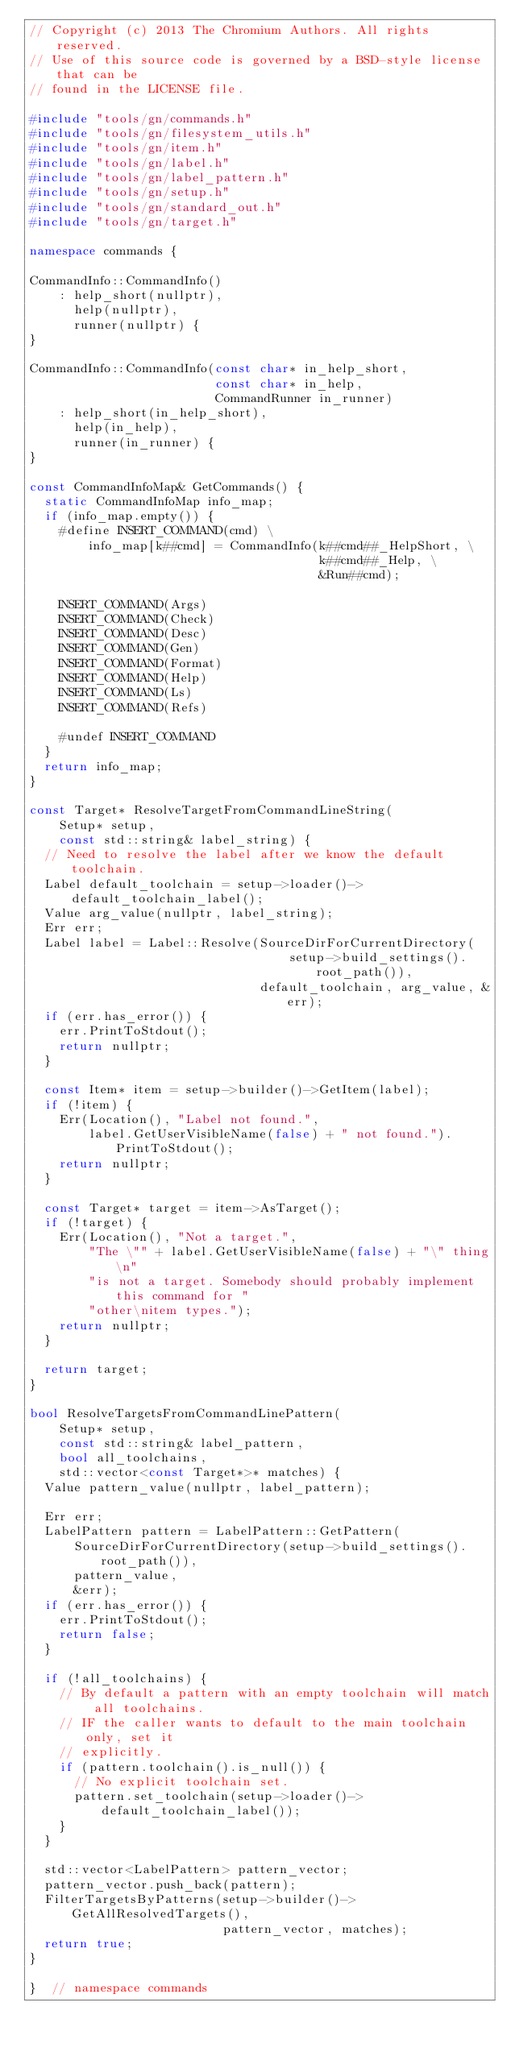Convert code to text. <code><loc_0><loc_0><loc_500><loc_500><_C++_>// Copyright (c) 2013 The Chromium Authors. All rights reserved.
// Use of this source code is governed by a BSD-style license that can be
// found in the LICENSE file.

#include "tools/gn/commands.h"
#include "tools/gn/filesystem_utils.h"
#include "tools/gn/item.h"
#include "tools/gn/label.h"
#include "tools/gn/label_pattern.h"
#include "tools/gn/setup.h"
#include "tools/gn/standard_out.h"
#include "tools/gn/target.h"

namespace commands {

CommandInfo::CommandInfo()
    : help_short(nullptr),
      help(nullptr),
      runner(nullptr) {
}

CommandInfo::CommandInfo(const char* in_help_short,
                         const char* in_help,
                         CommandRunner in_runner)
    : help_short(in_help_short),
      help(in_help),
      runner(in_runner) {
}

const CommandInfoMap& GetCommands() {
  static CommandInfoMap info_map;
  if (info_map.empty()) {
    #define INSERT_COMMAND(cmd) \
        info_map[k##cmd] = CommandInfo(k##cmd##_HelpShort, \
                                       k##cmd##_Help, \
                                       &Run##cmd);

    INSERT_COMMAND(Args)
    INSERT_COMMAND(Check)
    INSERT_COMMAND(Desc)
    INSERT_COMMAND(Gen)
    INSERT_COMMAND(Format)
    INSERT_COMMAND(Help)
    INSERT_COMMAND(Ls)
    INSERT_COMMAND(Refs)

    #undef INSERT_COMMAND
  }
  return info_map;
}

const Target* ResolveTargetFromCommandLineString(
    Setup* setup,
    const std::string& label_string) {
  // Need to resolve the label after we know the default toolchain.
  Label default_toolchain = setup->loader()->default_toolchain_label();
  Value arg_value(nullptr, label_string);
  Err err;
  Label label = Label::Resolve(SourceDirForCurrentDirectory(
                                   setup->build_settings().root_path()),
                               default_toolchain, arg_value, &err);
  if (err.has_error()) {
    err.PrintToStdout();
    return nullptr;
  }

  const Item* item = setup->builder()->GetItem(label);
  if (!item) {
    Err(Location(), "Label not found.",
        label.GetUserVisibleName(false) + " not found.").PrintToStdout();
    return nullptr;
  }

  const Target* target = item->AsTarget();
  if (!target) {
    Err(Location(), "Not a target.",
        "The \"" + label.GetUserVisibleName(false) + "\" thing\n"
        "is not a target. Somebody should probably implement this command for "
        "other\nitem types.");
    return nullptr;
  }

  return target;
}

bool ResolveTargetsFromCommandLinePattern(
    Setup* setup,
    const std::string& label_pattern,
    bool all_toolchains,
    std::vector<const Target*>* matches) {
  Value pattern_value(nullptr, label_pattern);

  Err err;
  LabelPattern pattern = LabelPattern::GetPattern(
      SourceDirForCurrentDirectory(setup->build_settings().root_path()),
      pattern_value,
      &err);
  if (err.has_error()) {
    err.PrintToStdout();
    return false;
  }

  if (!all_toolchains) {
    // By default a pattern with an empty toolchain will match all toolchains.
    // IF the caller wants to default to the main toolchain only, set it
    // explicitly.
    if (pattern.toolchain().is_null()) {
      // No explicit toolchain set.
      pattern.set_toolchain(setup->loader()->default_toolchain_label());
    }
  }

  std::vector<LabelPattern> pattern_vector;
  pattern_vector.push_back(pattern);
  FilterTargetsByPatterns(setup->builder()->GetAllResolvedTargets(),
                          pattern_vector, matches);
  return true;
}

}  // namespace commands
</code> 